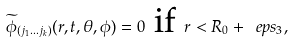<formula> <loc_0><loc_0><loc_500><loc_500>\widetilde { \phi } _ { ( j _ { 1 } \dots j _ { k } ) } ( r , t , \theta , \phi ) = 0 \text { if } r < R _ { 0 } + \ e p s _ { 3 } ,</formula> 